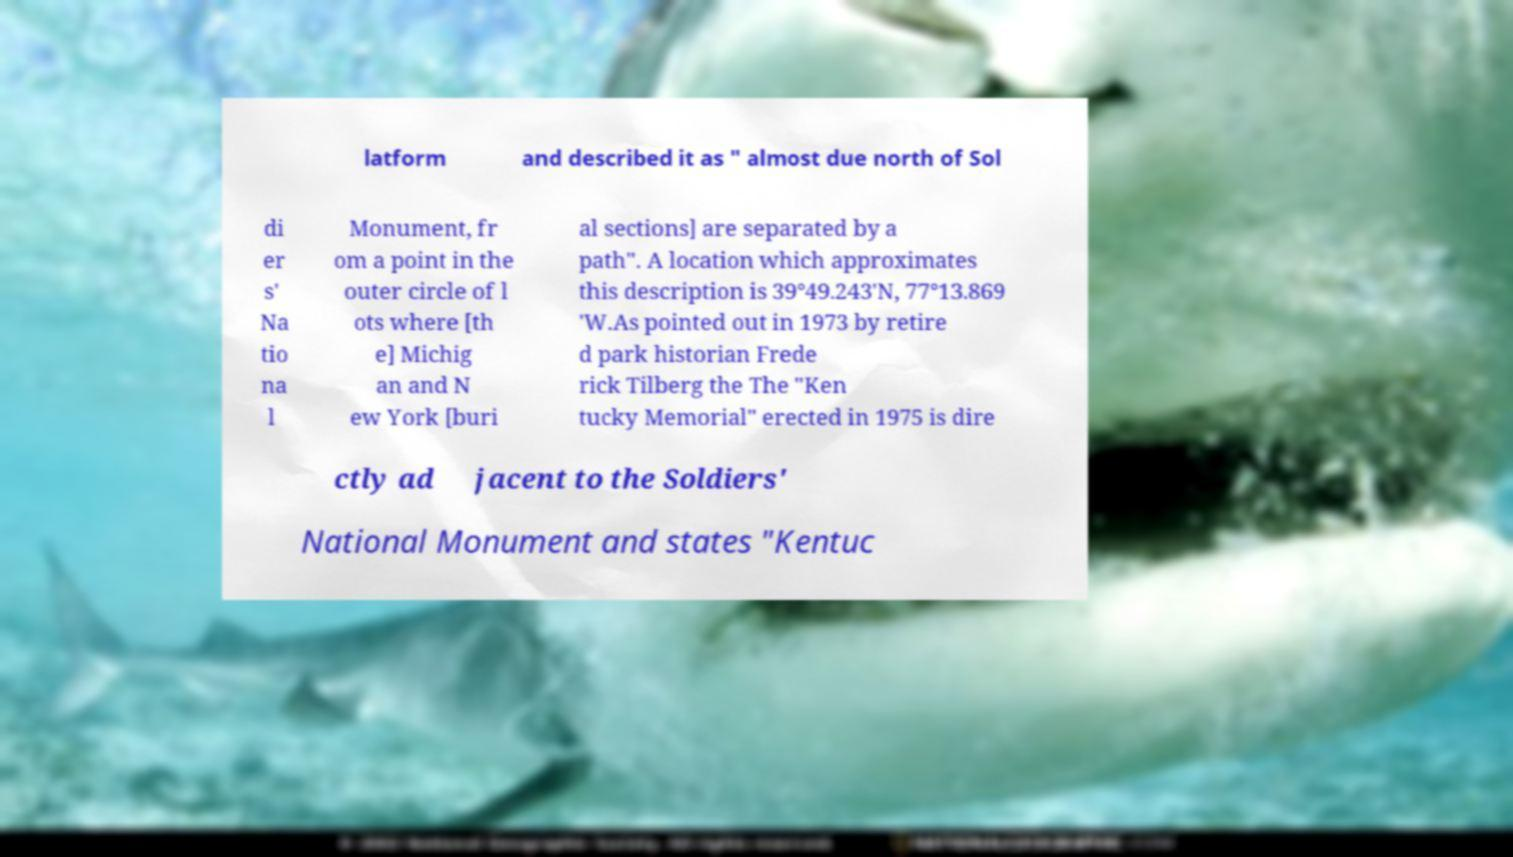What messages or text are displayed in this image? I need them in a readable, typed format. latform and described it as " almost due north of Sol di er s' Na tio na l Monument, fr om a point in the outer circle of l ots where [th e] Michig an and N ew York [buri al sections] are separated by a path". A location which approximates this description is 39°49.243′N, 77°13.869 ′W.As pointed out in 1973 by retire d park historian Frede rick Tilberg the The "Ken tucky Memorial" erected in 1975 is dire ctly ad jacent to the Soldiers' National Monument and states "Kentuc 